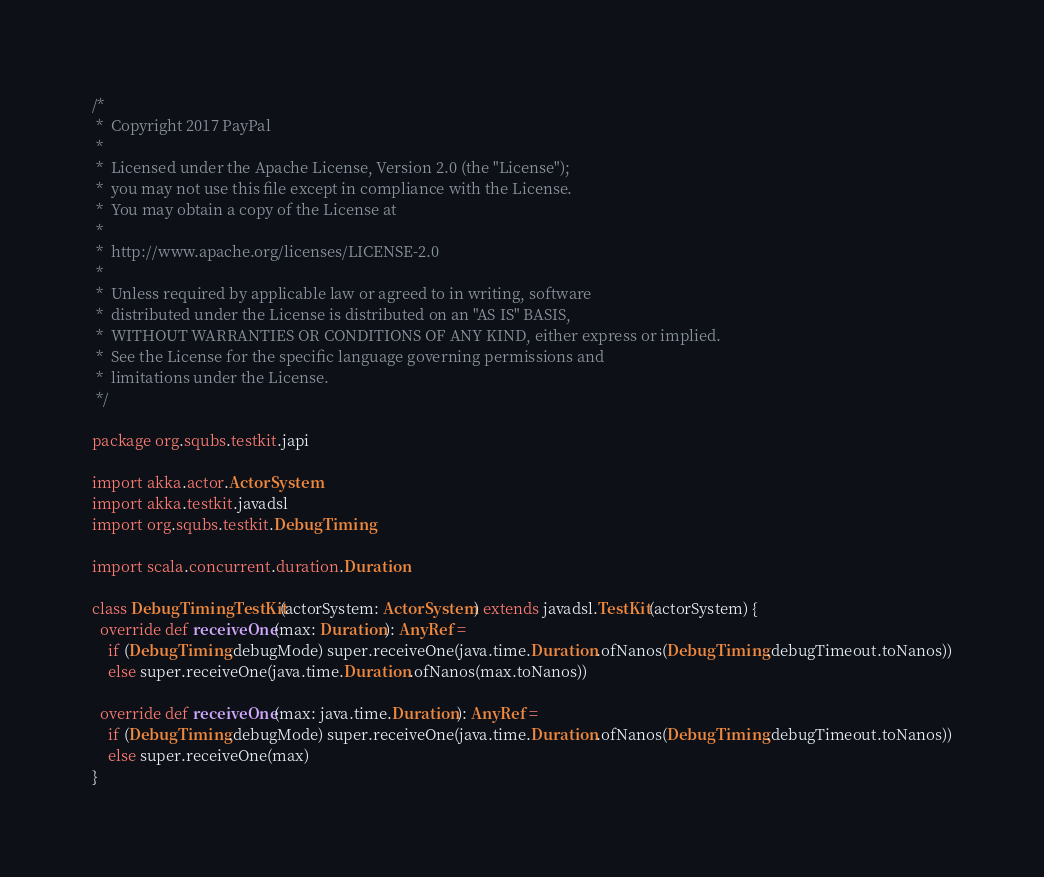<code> <loc_0><loc_0><loc_500><loc_500><_Scala_>/*
 *  Copyright 2017 PayPal
 *
 *  Licensed under the Apache License, Version 2.0 (the "License");
 *  you may not use this file except in compliance with the License.
 *  You may obtain a copy of the License at
 *
 *  http://www.apache.org/licenses/LICENSE-2.0
 *
 *  Unless required by applicable law or agreed to in writing, software
 *  distributed under the License is distributed on an "AS IS" BASIS,
 *  WITHOUT WARRANTIES OR CONDITIONS OF ANY KIND, either express or implied.
 *  See the License for the specific language governing permissions and
 *  limitations under the License.
 */

package org.squbs.testkit.japi

import akka.actor.ActorSystem
import akka.testkit.javadsl
import org.squbs.testkit.DebugTiming

import scala.concurrent.duration.Duration

class DebugTimingTestKit(actorSystem: ActorSystem) extends javadsl.TestKit(actorSystem) {
  override def receiveOne(max: Duration): AnyRef =
    if (DebugTiming.debugMode) super.receiveOne(java.time.Duration.ofNanos(DebugTiming.debugTimeout.toNanos))
    else super.receiveOne(java.time.Duration.ofNanos(max.toNanos))

  override def receiveOne(max: java.time.Duration): AnyRef =
    if (DebugTiming.debugMode) super.receiveOne(java.time.Duration.ofNanos(DebugTiming.debugTimeout.toNanos))
    else super.receiveOne(max)
}
</code> 